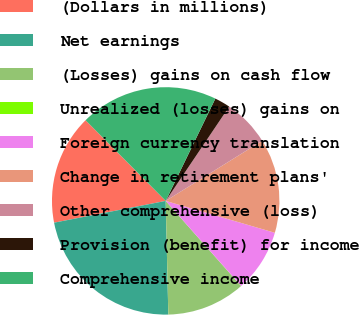Convert chart. <chart><loc_0><loc_0><loc_500><loc_500><pie_chart><fcel>(Dollars in millions)<fcel>Net earnings<fcel>(Losses) gains on cash flow<fcel>Unrealized (losses) gains on<fcel>Foreign currency translation<fcel>Change in retirement plans'<fcel>Other comprehensive (loss)<fcel>Provision (benefit) for income<fcel>Comprehensive income<nl><fcel>15.62%<fcel>22.3%<fcel>11.16%<fcel>0.02%<fcel>8.93%<fcel>13.39%<fcel>6.7%<fcel>2.24%<fcel>19.64%<nl></chart> 